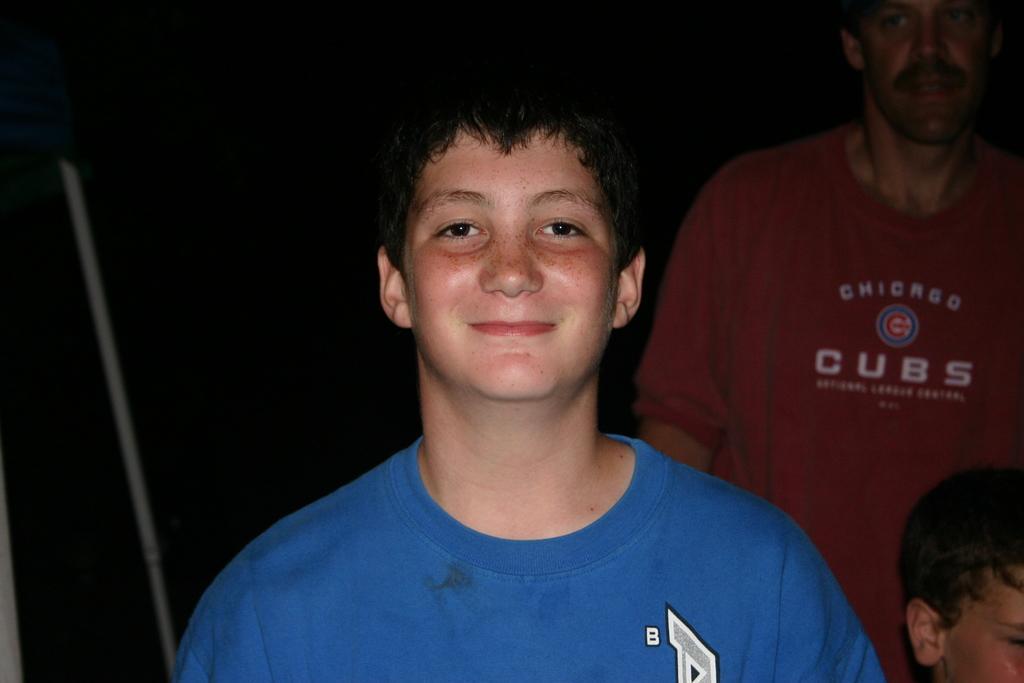Could you give a brief overview of what you see in this image? In the image in the center, we can see one person standing and smiling. In the background, we can see two persons and a few other objects. 